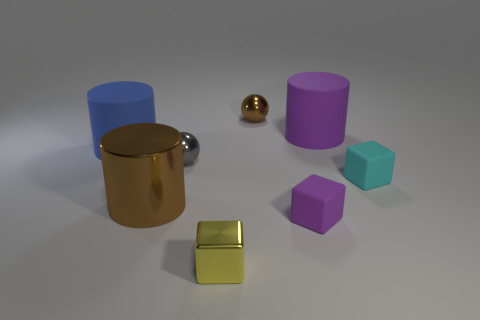What shape is the small metal object that is the same color as the big shiny cylinder?
Your answer should be compact. Sphere. Do the blue rubber cylinder and the gray ball have the same size?
Provide a succinct answer. No. There is a tiny metal thing that is behind the gray object; does it have the same color as the large metallic cylinder?
Your answer should be compact. Yes. Do the brown thing that is left of the gray metallic ball and the yellow block have the same size?
Provide a succinct answer. No. There is a metallic cylinder; does it have the same color as the small metal sphere that is behind the big blue rubber thing?
Ensure brevity in your answer.  Yes. The matte thing to the left of the metal ball in front of the matte object left of the large brown metallic cylinder is what color?
Offer a very short reply. Blue. The other large rubber object that is the same shape as the large purple matte object is what color?
Your answer should be compact. Blue. Is the number of cylinders to the right of the brown metal sphere the same as the number of big brown rubber blocks?
Make the answer very short. No. What number of spheres are large purple things or brown metallic objects?
Your response must be concise. 1. What is the color of the small ball that is the same material as the tiny brown thing?
Provide a short and direct response. Gray. 